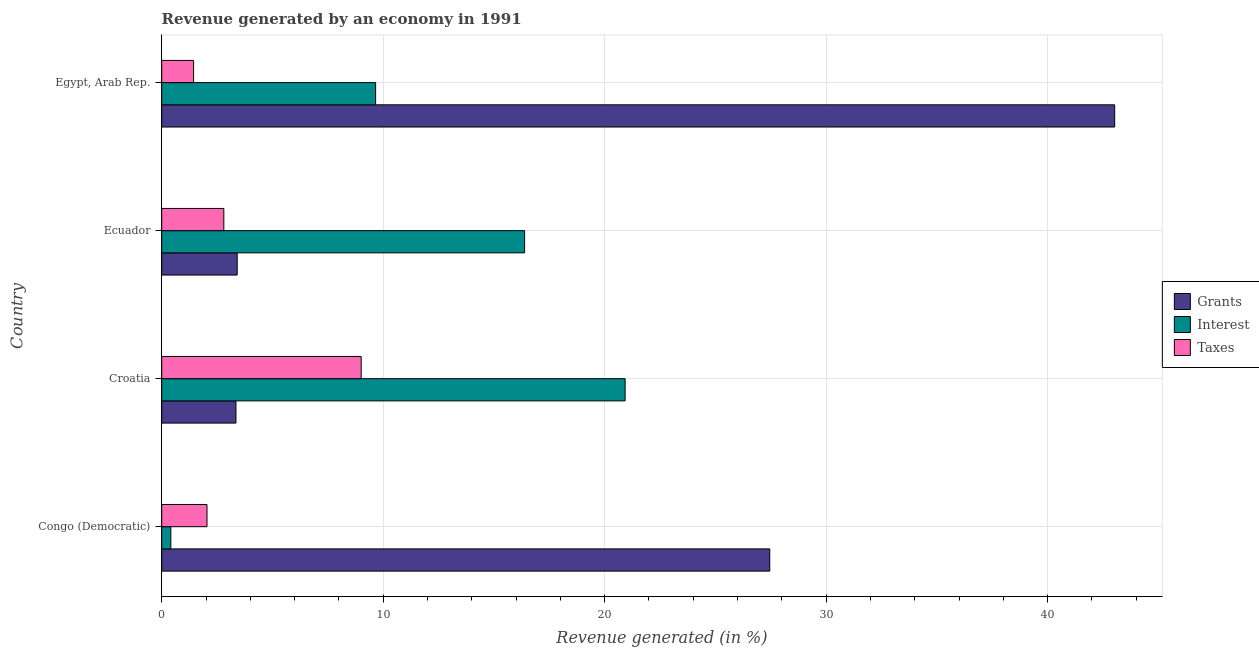How many groups of bars are there?
Your answer should be very brief. 4. Are the number of bars per tick equal to the number of legend labels?
Offer a terse response. Yes. Are the number of bars on each tick of the Y-axis equal?
Give a very brief answer. Yes. How many bars are there on the 2nd tick from the top?
Ensure brevity in your answer.  3. What is the label of the 4th group of bars from the top?
Offer a terse response. Congo (Democratic). What is the percentage of revenue generated by interest in Egypt, Arab Rep.?
Ensure brevity in your answer.  9.66. Across all countries, what is the maximum percentage of revenue generated by grants?
Provide a short and direct response. 43.03. Across all countries, what is the minimum percentage of revenue generated by grants?
Offer a very short reply. 3.35. In which country was the percentage of revenue generated by taxes maximum?
Your answer should be very brief. Croatia. In which country was the percentage of revenue generated by taxes minimum?
Provide a short and direct response. Egypt, Arab Rep. What is the total percentage of revenue generated by taxes in the graph?
Make the answer very short. 15.29. What is the difference between the percentage of revenue generated by interest in Congo (Democratic) and that in Egypt, Arab Rep.?
Keep it short and to the point. -9.24. What is the difference between the percentage of revenue generated by interest in Ecuador and the percentage of revenue generated by grants in Egypt, Arab Rep.?
Keep it short and to the point. -26.64. What is the average percentage of revenue generated by taxes per country?
Your answer should be very brief. 3.82. What is the difference between the percentage of revenue generated by grants and percentage of revenue generated by taxes in Congo (Democratic)?
Provide a short and direct response. 25.41. In how many countries, is the percentage of revenue generated by interest greater than 28 %?
Make the answer very short. 0. What is the ratio of the percentage of revenue generated by interest in Congo (Democratic) to that in Ecuador?
Offer a very short reply. 0.03. Is the percentage of revenue generated by grants in Congo (Democratic) less than that in Egypt, Arab Rep.?
Offer a terse response. Yes. Is the difference between the percentage of revenue generated by grants in Congo (Democratic) and Croatia greater than the difference between the percentage of revenue generated by taxes in Congo (Democratic) and Croatia?
Provide a short and direct response. Yes. What is the difference between the highest and the second highest percentage of revenue generated by taxes?
Offer a terse response. 6.2. What is the difference between the highest and the lowest percentage of revenue generated by taxes?
Provide a succinct answer. 7.57. What does the 2nd bar from the top in Congo (Democratic) represents?
Offer a very short reply. Interest. What does the 3rd bar from the bottom in Congo (Democratic) represents?
Your answer should be compact. Taxes. How many bars are there?
Ensure brevity in your answer.  12. Are all the bars in the graph horizontal?
Ensure brevity in your answer.  Yes. How many countries are there in the graph?
Make the answer very short. 4. What is the difference between two consecutive major ticks on the X-axis?
Give a very brief answer. 10. Does the graph contain any zero values?
Keep it short and to the point. No. Does the graph contain grids?
Give a very brief answer. Yes. Where does the legend appear in the graph?
Your answer should be very brief. Center right. How many legend labels are there?
Offer a very short reply. 3. How are the legend labels stacked?
Your response must be concise. Vertical. What is the title of the graph?
Your answer should be very brief. Revenue generated by an economy in 1991. Does "Social insurance" appear as one of the legend labels in the graph?
Make the answer very short. No. What is the label or title of the X-axis?
Your response must be concise. Revenue generated (in %). What is the label or title of the Y-axis?
Your response must be concise. Country. What is the Revenue generated (in %) in Grants in Congo (Democratic)?
Provide a succinct answer. 27.45. What is the Revenue generated (in %) in Interest in Congo (Democratic)?
Your answer should be compact. 0.41. What is the Revenue generated (in %) of Taxes in Congo (Democratic)?
Keep it short and to the point. 2.05. What is the Revenue generated (in %) of Grants in Croatia?
Offer a terse response. 3.35. What is the Revenue generated (in %) of Interest in Croatia?
Offer a terse response. 20.92. What is the Revenue generated (in %) of Taxes in Croatia?
Your answer should be very brief. 9.01. What is the Revenue generated (in %) of Grants in Ecuador?
Provide a short and direct response. 3.41. What is the Revenue generated (in %) of Interest in Ecuador?
Ensure brevity in your answer.  16.38. What is the Revenue generated (in %) in Taxes in Ecuador?
Make the answer very short. 2.8. What is the Revenue generated (in %) of Grants in Egypt, Arab Rep.?
Provide a short and direct response. 43.03. What is the Revenue generated (in %) in Interest in Egypt, Arab Rep.?
Ensure brevity in your answer.  9.66. What is the Revenue generated (in %) in Taxes in Egypt, Arab Rep.?
Ensure brevity in your answer.  1.44. Across all countries, what is the maximum Revenue generated (in %) in Grants?
Keep it short and to the point. 43.03. Across all countries, what is the maximum Revenue generated (in %) in Interest?
Offer a very short reply. 20.92. Across all countries, what is the maximum Revenue generated (in %) of Taxes?
Ensure brevity in your answer.  9.01. Across all countries, what is the minimum Revenue generated (in %) in Grants?
Your answer should be very brief. 3.35. Across all countries, what is the minimum Revenue generated (in %) of Interest?
Offer a terse response. 0.41. Across all countries, what is the minimum Revenue generated (in %) of Taxes?
Give a very brief answer. 1.44. What is the total Revenue generated (in %) of Grants in the graph?
Keep it short and to the point. 77.24. What is the total Revenue generated (in %) of Interest in the graph?
Your answer should be compact. 47.38. What is the total Revenue generated (in %) in Taxes in the graph?
Your response must be concise. 15.29. What is the difference between the Revenue generated (in %) of Grants in Congo (Democratic) and that in Croatia?
Offer a terse response. 24.1. What is the difference between the Revenue generated (in %) of Interest in Congo (Democratic) and that in Croatia?
Make the answer very short. -20.51. What is the difference between the Revenue generated (in %) in Taxes in Congo (Democratic) and that in Croatia?
Your response must be concise. -6.96. What is the difference between the Revenue generated (in %) in Grants in Congo (Democratic) and that in Ecuador?
Your answer should be compact. 24.05. What is the difference between the Revenue generated (in %) of Interest in Congo (Democratic) and that in Ecuador?
Make the answer very short. -15.97. What is the difference between the Revenue generated (in %) of Taxes in Congo (Democratic) and that in Ecuador?
Provide a succinct answer. -0.76. What is the difference between the Revenue generated (in %) in Grants in Congo (Democratic) and that in Egypt, Arab Rep.?
Your answer should be compact. -15.57. What is the difference between the Revenue generated (in %) in Interest in Congo (Democratic) and that in Egypt, Arab Rep.?
Offer a very short reply. -9.25. What is the difference between the Revenue generated (in %) in Taxes in Congo (Democratic) and that in Egypt, Arab Rep.?
Make the answer very short. 0.61. What is the difference between the Revenue generated (in %) in Grants in Croatia and that in Ecuador?
Keep it short and to the point. -0.06. What is the difference between the Revenue generated (in %) in Interest in Croatia and that in Ecuador?
Give a very brief answer. 4.54. What is the difference between the Revenue generated (in %) of Taxes in Croatia and that in Ecuador?
Give a very brief answer. 6.2. What is the difference between the Revenue generated (in %) of Grants in Croatia and that in Egypt, Arab Rep.?
Offer a terse response. -39.68. What is the difference between the Revenue generated (in %) of Interest in Croatia and that in Egypt, Arab Rep.?
Your answer should be very brief. 11.27. What is the difference between the Revenue generated (in %) in Taxes in Croatia and that in Egypt, Arab Rep.?
Offer a very short reply. 7.57. What is the difference between the Revenue generated (in %) of Grants in Ecuador and that in Egypt, Arab Rep.?
Give a very brief answer. -39.62. What is the difference between the Revenue generated (in %) of Interest in Ecuador and that in Egypt, Arab Rep.?
Offer a terse response. 6.73. What is the difference between the Revenue generated (in %) of Taxes in Ecuador and that in Egypt, Arab Rep.?
Provide a succinct answer. 1.37. What is the difference between the Revenue generated (in %) of Grants in Congo (Democratic) and the Revenue generated (in %) of Interest in Croatia?
Provide a short and direct response. 6.53. What is the difference between the Revenue generated (in %) in Grants in Congo (Democratic) and the Revenue generated (in %) in Taxes in Croatia?
Your response must be concise. 18.45. What is the difference between the Revenue generated (in %) in Interest in Congo (Democratic) and the Revenue generated (in %) in Taxes in Croatia?
Ensure brevity in your answer.  -8.59. What is the difference between the Revenue generated (in %) of Grants in Congo (Democratic) and the Revenue generated (in %) of Interest in Ecuador?
Ensure brevity in your answer.  11.07. What is the difference between the Revenue generated (in %) of Grants in Congo (Democratic) and the Revenue generated (in %) of Taxes in Ecuador?
Your answer should be very brief. 24.65. What is the difference between the Revenue generated (in %) of Interest in Congo (Democratic) and the Revenue generated (in %) of Taxes in Ecuador?
Provide a succinct answer. -2.39. What is the difference between the Revenue generated (in %) of Grants in Congo (Democratic) and the Revenue generated (in %) of Interest in Egypt, Arab Rep.?
Make the answer very short. 17.8. What is the difference between the Revenue generated (in %) of Grants in Congo (Democratic) and the Revenue generated (in %) of Taxes in Egypt, Arab Rep.?
Offer a very short reply. 26.02. What is the difference between the Revenue generated (in %) in Interest in Congo (Democratic) and the Revenue generated (in %) in Taxes in Egypt, Arab Rep.?
Make the answer very short. -1.03. What is the difference between the Revenue generated (in %) of Grants in Croatia and the Revenue generated (in %) of Interest in Ecuador?
Keep it short and to the point. -13.03. What is the difference between the Revenue generated (in %) of Grants in Croatia and the Revenue generated (in %) of Taxes in Ecuador?
Your answer should be very brief. 0.55. What is the difference between the Revenue generated (in %) of Interest in Croatia and the Revenue generated (in %) of Taxes in Ecuador?
Give a very brief answer. 18.12. What is the difference between the Revenue generated (in %) in Grants in Croatia and the Revenue generated (in %) in Interest in Egypt, Arab Rep.?
Your response must be concise. -6.31. What is the difference between the Revenue generated (in %) of Grants in Croatia and the Revenue generated (in %) of Taxes in Egypt, Arab Rep.?
Provide a succinct answer. 1.91. What is the difference between the Revenue generated (in %) in Interest in Croatia and the Revenue generated (in %) in Taxes in Egypt, Arab Rep.?
Your answer should be compact. 19.48. What is the difference between the Revenue generated (in %) of Grants in Ecuador and the Revenue generated (in %) of Interest in Egypt, Arab Rep.?
Offer a terse response. -6.25. What is the difference between the Revenue generated (in %) of Grants in Ecuador and the Revenue generated (in %) of Taxes in Egypt, Arab Rep.?
Make the answer very short. 1.97. What is the difference between the Revenue generated (in %) in Interest in Ecuador and the Revenue generated (in %) in Taxes in Egypt, Arab Rep.?
Your response must be concise. 14.95. What is the average Revenue generated (in %) of Grants per country?
Give a very brief answer. 19.31. What is the average Revenue generated (in %) of Interest per country?
Provide a short and direct response. 11.84. What is the average Revenue generated (in %) in Taxes per country?
Your response must be concise. 3.82. What is the difference between the Revenue generated (in %) of Grants and Revenue generated (in %) of Interest in Congo (Democratic)?
Provide a succinct answer. 27.04. What is the difference between the Revenue generated (in %) of Grants and Revenue generated (in %) of Taxes in Congo (Democratic)?
Your answer should be very brief. 25.41. What is the difference between the Revenue generated (in %) of Interest and Revenue generated (in %) of Taxes in Congo (Democratic)?
Make the answer very short. -1.63. What is the difference between the Revenue generated (in %) of Grants and Revenue generated (in %) of Interest in Croatia?
Your answer should be very brief. -17.57. What is the difference between the Revenue generated (in %) of Grants and Revenue generated (in %) of Taxes in Croatia?
Make the answer very short. -5.65. What is the difference between the Revenue generated (in %) in Interest and Revenue generated (in %) in Taxes in Croatia?
Offer a terse response. 11.92. What is the difference between the Revenue generated (in %) in Grants and Revenue generated (in %) in Interest in Ecuador?
Your answer should be compact. -12.98. What is the difference between the Revenue generated (in %) of Grants and Revenue generated (in %) of Taxes in Ecuador?
Give a very brief answer. 0.6. What is the difference between the Revenue generated (in %) of Interest and Revenue generated (in %) of Taxes in Ecuador?
Offer a very short reply. 13.58. What is the difference between the Revenue generated (in %) in Grants and Revenue generated (in %) in Interest in Egypt, Arab Rep.?
Ensure brevity in your answer.  33.37. What is the difference between the Revenue generated (in %) of Grants and Revenue generated (in %) of Taxes in Egypt, Arab Rep.?
Provide a succinct answer. 41.59. What is the difference between the Revenue generated (in %) in Interest and Revenue generated (in %) in Taxes in Egypt, Arab Rep.?
Keep it short and to the point. 8.22. What is the ratio of the Revenue generated (in %) in Grants in Congo (Democratic) to that in Croatia?
Offer a terse response. 8.19. What is the ratio of the Revenue generated (in %) in Interest in Congo (Democratic) to that in Croatia?
Offer a terse response. 0.02. What is the ratio of the Revenue generated (in %) of Taxes in Congo (Democratic) to that in Croatia?
Make the answer very short. 0.23. What is the ratio of the Revenue generated (in %) of Grants in Congo (Democratic) to that in Ecuador?
Your response must be concise. 8.05. What is the ratio of the Revenue generated (in %) of Interest in Congo (Democratic) to that in Ecuador?
Your answer should be very brief. 0.03. What is the ratio of the Revenue generated (in %) of Taxes in Congo (Democratic) to that in Ecuador?
Offer a terse response. 0.73. What is the ratio of the Revenue generated (in %) in Grants in Congo (Democratic) to that in Egypt, Arab Rep.?
Make the answer very short. 0.64. What is the ratio of the Revenue generated (in %) of Interest in Congo (Democratic) to that in Egypt, Arab Rep.?
Offer a very short reply. 0.04. What is the ratio of the Revenue generated (in %) of Taxes in Congo (Democratic) to that in Egypt, Arab Rep.?
Your answer should be very brief. 1.42. What is the ratio of the Revenue generated (in %) of Grants in Croatia to that in Ecuador?
Give a very brief answer. 0.98. What is the ratio of the Revenue generated (in %) in Interest in Croatia to that in Ecuador?
Your response must be concise. 1.28. What is the ratio of the Revenue generated (in %) in Taxes in Croatia to that in Ecuador?
Your answer should be very brief. 3.21. What is the ratio of the Revenue generated (in %) in Grants in Croatia to that in Egypt, Arab Rep.?
Provide a succinct answer. 0.08. What is the ratio of the Revenue generated (in %) in Interest in Croatia to that in Egypt, Arab Rep.?
Ensure brevity in your answer.  2.17. What is the ratio of the Revenue generated (in %) of Taxes in Croatia to that in Egypt, Arab Rep.?
Make the answer very short. 6.26. What is the ratio of the Revenue generated (in %) in Grants in Ecuador to that in Egypt, Arab Rep.?
Ensure brevity in your answer.  0.08. What is the ratio of the Revenue generated (in %) in Interest in Ecuador to that in Egypt, Arab Rep.?
Keep it short and to the point. 1.7. What is the ratio of the Revenue generated (in %) of Taxes in Ecuador to that in Egypt, Arab Rep.?
Provide a short and direct response. 1.95. What is the difference between the highest and the second highest Revenue generated (in %) in Grants?
Give a very brief answer. 15.57. What is the difference between the highest and the second highest Revenue generated (in %) in Interest?
Ensure brevity in your answer.  4.54. What is the difference between the highest and the second highest Revenue generated (in %) of Taxes?
Provide a short and direct response. 6.2. What is the difference between the highest and the lowest Revenue generated (in %) of Grants?
Ensure brevity in your answer.  39.68. What is the difference between the highest and the lowest Revenue generated (in %) of Interest?
Offer a very short reply. 20.51. What is the difference between the highest and the lowest Revenue generated (in %) of Taxes?
Offer a terse response. 7.57. 